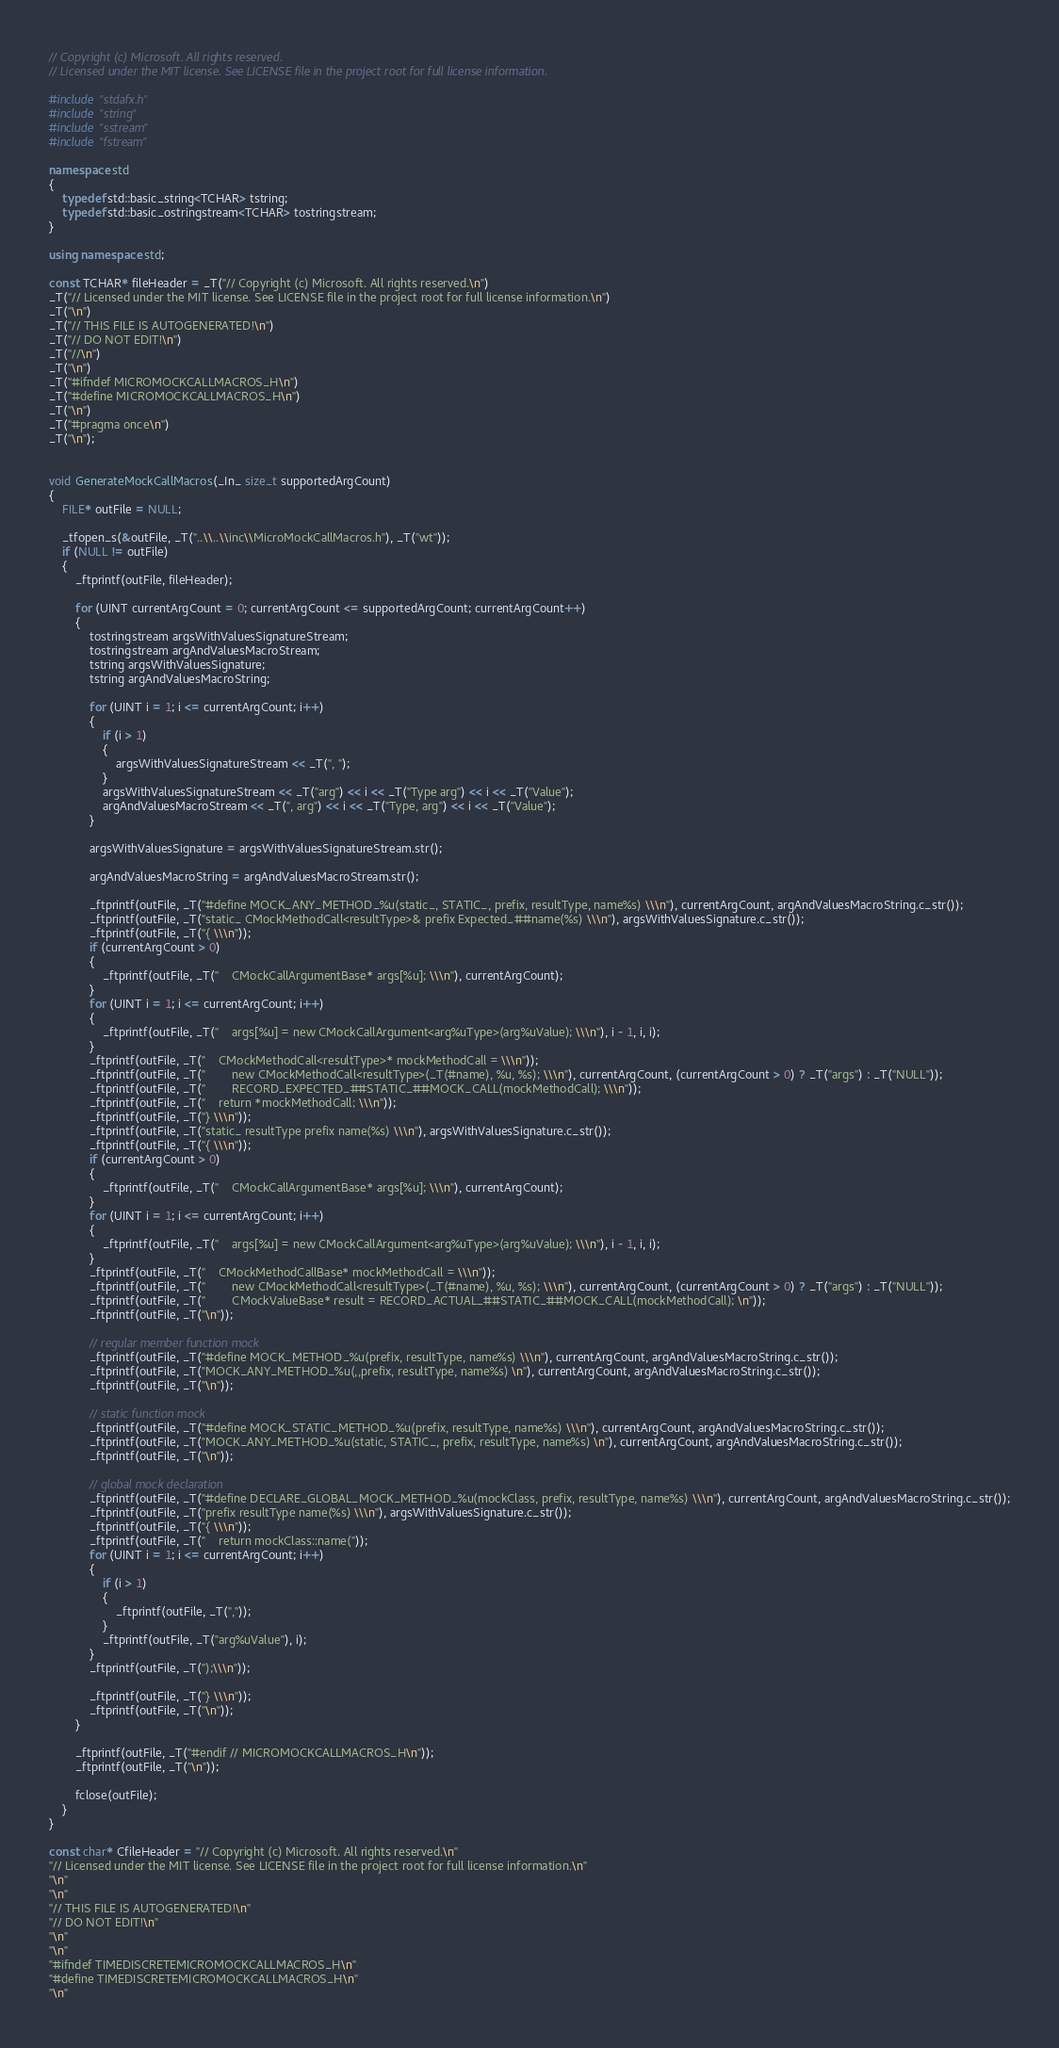<code> <loc_0><loc_0><loc_500><loc_500><_C++_>// Copyright (c) Microsoft. All rights reserved.
// Licensed under the MIT license. See LICENSE file in the project root for full license information.

#include "stdafx.h"
#include "string"
#include "sstream"
#include "fstream"

namespace std
{
    typedef std::basic_string<TCHAR> tstring;
    typedef std::basic_ostringstream<TCHAR> tostringstream;
}

using namespace std;

const TCHAR* fileHeader = _T("// Copyright (c) Microsoft. All rights reserved.\n")
_T("// Licensed under the MIT license. See LICENSE file in the project root for full license information.\n")
_T("\n")
_T("// THIS FILE IS AUTOGENERATED!\n")
_T("// DO NOT EDIT!\n")
_T("//\n")
_T("\n")
_T("#ifndef MICROMOCKCALLMACROS_H\n")
_T("#define MICROMOCKCALLMACROS_H\n")
_T("\n")
_T("#pragma once\n")
_T("\n");


void GenerateMockCallMacros(_In_ size_t supportedArgCount)
{
    FILE* outFile = NULL;

    _tfopen_s(&outFile, _T("..\\..\\inc\\MicroMockCallMacros.h"), _T("wt"));
    if (NULL != outFile)
    {
        _ftprintf(outFile, fileHeader);

        for (UINT currentArgCount = 0; currentArgCount <= supportedArgCount; currentArgCount++)
        {
            tostringstream argsWithValuesSignatureStream;
            tostringstream argAndValuesMacroStream;
            tstring argsWithValuesSignature;
            tstring argAndValuesMacroString;

            for (UINT i = 1; i <= currentArgCount; i++)
            {
                if (i > 1)
                {
                    argsWithValuesSignatureStream << _T(", ");
                }
                argsWithValuesSignatureStream << _T("arg") << i << _T("Type arg") << i << _T("Value");
                argAndValuesMacroStream << _T(", arg") << i << _T("Type, arg") << i << _T("Value");
            }

            argsWithValuesSignature = argsWithValuesSignatureStream.str();

            argAndValuesMacroString = argAndValuesMacroStream.str();

            _ftprintf(outFile, _T("#define MOCK_ANY_METHOD_%u(static_, STATIC_, prefix, resultType, name%s) \\\n"), currentArgCount, argAndValuesMacroString.c_str());
            _ftprintf(outFile, _T("static_ CMockMethodCall<resultType>& prefix Expected_##name(%s) \\\n"), argsWithValuesSignature.c_str());
            _ftprintf(outFile, _T("{ \\\n"));
            if (currentArgCount > 0)
            {
                _ftprintf(outFile, _T("    CMockCallArgumentBase* args[%u]; \\\n"), currentArgCount);
            }
            for (UINT i = 1; i <= currentArgCount; i++)
            {
                _ftprintf(outFile, _T("    args[%u] = new CMockCallArgument<arg%uType>(arg%uValue); \\\n"), i - 1, i, i);
            }
            _ftprintf(outFile, _T("    CMockMethodCall<resultType>* mockMethodCall = \\\n"));
            _ftprintf(outFile, _T("        new CMockMethodCall<resultType>(_T(#name), %u, %s); \\\n"), currentArgCount, (currentArgCount > 0) ? _T("args") : _T("NULL"));
            _ftprintf(outFile, _T("        RECORD_EXPECTED_##STATIC_##MOCK_CALL(mockMethodCall); \\\n"));
            _ftprintf(outFile, _T("    return *mockMethodCall; \\\n"));
            _ftprintf(outFile, _T("} \\\n"));
            _ftprintf(outFile, _T("static_ resultType prefix name(%s) \\\n"), argsWithValuesSignature.c_str());
            _ftprintf(outFile, _T("{ \\\n"));
            if (currentArgCount > 0)
            {
                _ftprintf(outFile, _T("    CMockCallArgumentBase* args[%u]; \\\n"), currentArgCount);
            }
            for (UINT i = 1; i <= currentArgCount; i++)
            {
                _ftprintf(outFile, _T("    args[%u] = new CMockCallArgument<arg%uType>(arg%uValue); \\\n"), i - 1, i, i);
            }
            _ftprintf(outFile, _T("    CMockMethodCallBase* mockMethodCall = \\\n"));
            _ftprintf(outFile, _T("        new CMockMethodCall<resultType>(_T(#name), %u, %s); \\\n"), currentArgCount, (currentArgCount > 0) ? _T("args") : _T("NULL"));
            _ftprintf(outFile, _T("        CMockValueBase* result = RECORD_ACTUAL_##STATIC_##MOCK_CALL(mockMethodCall); \n"));
            _ftprintf(outFile, _T("\n"));

            // regular member function mock
            _ftprintf(outFile, _T("#define MOCK_METHOD_%u(prefix, resultType, name%s) \\\n"), currentArgCount, argAndValuesMacroString.c_str());
            _ftprintf(outFile, _T("MOCK_ANY_METHOD_%u(,,prefix, resultType, name%s) \n"), currentArgCount, argAndValuesMacroString.c_str());
            _ftprintf(outFile, _T("\n"));

            // static function mock
            _ftprintf(outFile, _T("#define MOCK_STATIC_METHOD_%u(prefix, resultType, name%s) \\\n"), currentArgCount, argAndValuesMacroString.c_str());
            _ftprintf(outFile, _T("MOCK_ANY_METHOD_%u(static, STATIC_, prefix, resultType, name%s) \n"), currentArgCount, argAndValuesMacroString.c_str());
            _ftprintf(outFile, _T("\n"));

            // global mock declaration
            _ftprintf(outFile, _T("#define DECLARE_GLOBAL_MOCK_METHOD_%u(mockClass, prefix, resultType, name%s) \\\n"), currentArgCount, argAndValuesMacroString.c_str());
            _ftprintf(outFile, _T("prefix resultType name(%s) \\\n"), argsWithValuesSignature.c_str());
            _ftprintf(outFile, _T("{ \\\n"));
            _ftprintf(outFile, _T("    return mockClass::name("));
            for (UINT i = 1; i <= currentArgCount; i++)
            {
                if (i > 1)
                {
                    _ftprintf(outFile, _T(","));
                }
                _ftprintf(outFile, _T("arg%uValue"), i);
            }
            _ftprintf(outFile, _T(");\\\n"));
            
            _ftprintf(outFile, _T("} \\\n"));
            _ftprintf(outFile, _T("\n"));
        }

        _ftprintf(outFile, _T("#endif // MICROMOCKCALLMACROS_H\n"));
        _ftprintf(outFile, _T("\n"));

        fclose(outFile);
    }
}

const char* CfileHeader = "// Copyright (c) Microsoft. All rights reserved.\n"
"// Licensed under the MIT license. See LICENSE file in the project root for full license information.\n"
"\n"
"\n"
"// THIS FILE IS AUTOGENERATED!\n"
"// DO NOT EDIT!\n"
"\n"
"\n"
"#ifndef TIMEDISCRETEMICROMOCKCALLMACROS_H\n"
"#define TIMEDISCRETEMICROMOCKCALLMACROS_H\n"
"\n"</code> 